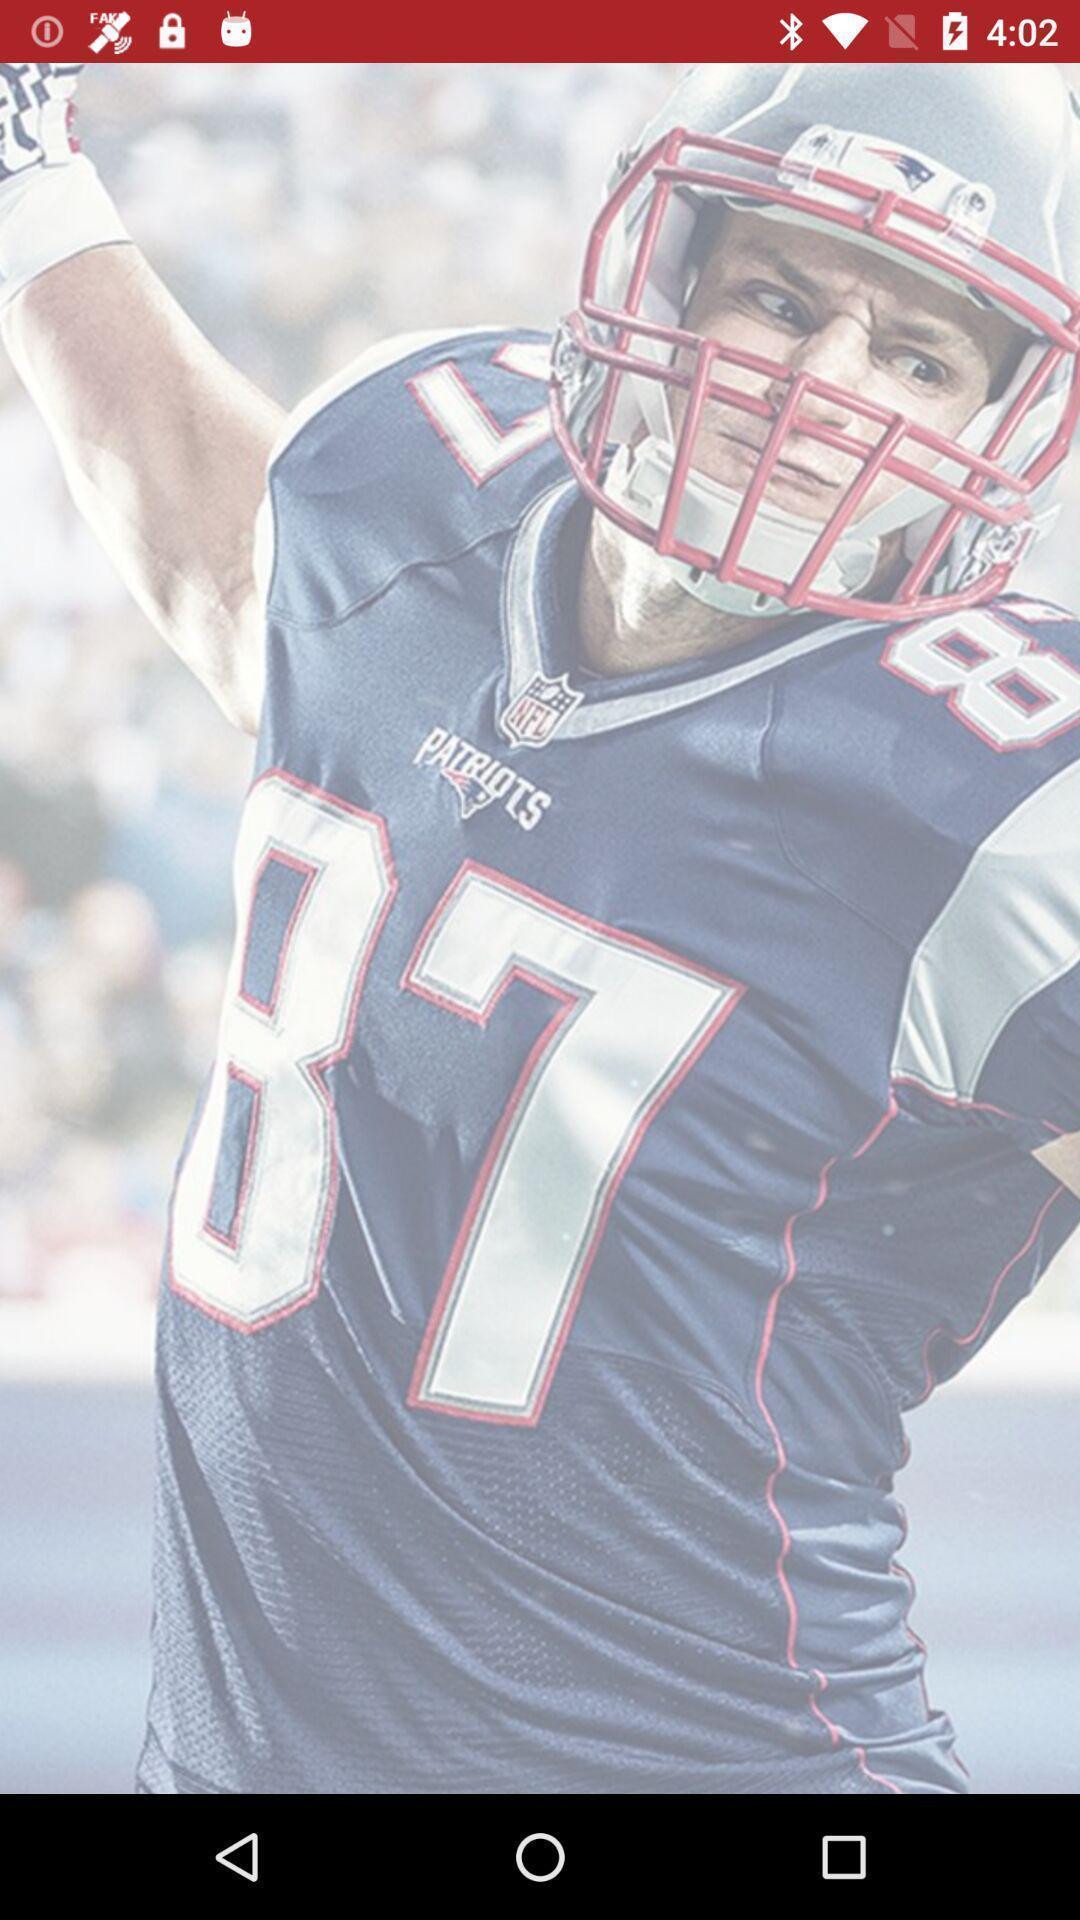Give me a narrative description of this picture. Screen shows image of a sports person. 